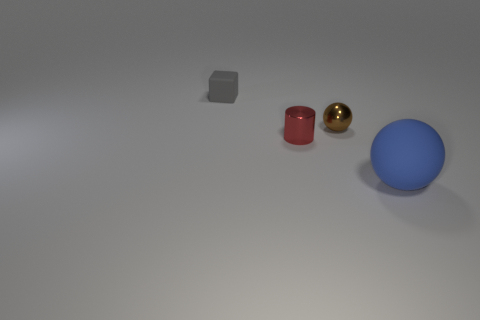What is the material of the tiny thing to the right of the small metal cylinder?
Give a very brief answer. Metal. Is the number of large cyan cubes greater than the number of red objects?
Offer a terse response. No. There is a small metallic object left of the brown shiny thing; is it the same shape as the gray thing?
Offer a very short reply. No. How many things are both behind the large blue object and in front of the brown object?
Provide a succinct answer. 1. What number of gray objects are the same shape as the small brown object?
Provide a short and direct response. 0. What is the color of the sphere that is to the left of the object that is in front of the red metallic thing?
Ensure brevity in your answer.  Brown. There is a brown thing; does it have the same shape as the thing that is to the left of the cylinder?
Keep it short and to the point. No. What material is the object right of the ball behind the matte thing that is in front of the red metallic cylinder?
Offer a terse response. Rubber. Is there a shiny ball of the same size as the red cylinder?
Give a very brief answer. Yes. What is the size of the other gray thing that is made of the same material as the big object?
Your response must be concise. Small. 